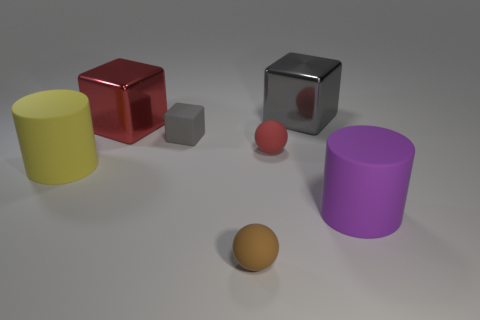Add 2 red balls. How many objects exist? 9 Subtract all cylinders. How many objects are left? 5 Add 5 big rubber cylinders. How many big rubber cylinders exist? 7 Subtract 1 purple cylinders. How many objects are left? 6 Subtract all big gray metallic things. Subtract all brown matte spheres. How many objects are left? 5 Add 7 purple things. How many purple things are left? 8 